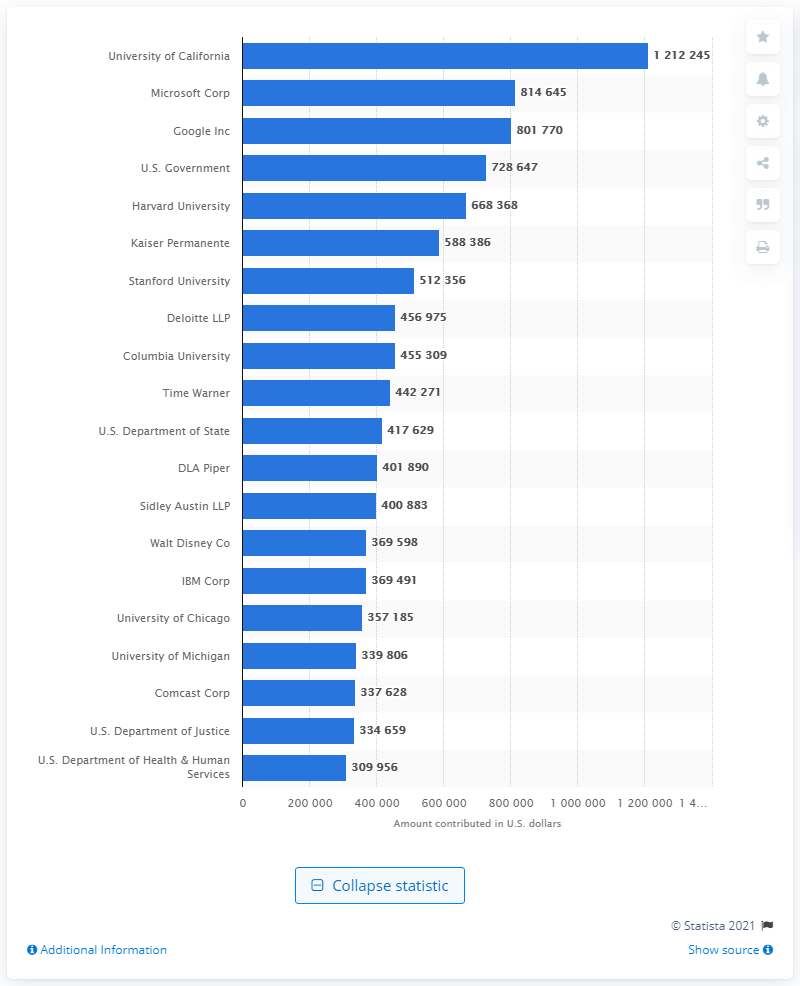List a handful of essential elements in this visual. The University of California was the most significant donor to the Obama campaign. Microsoft Corporation was the second most significant donor to the Obama campaign. 